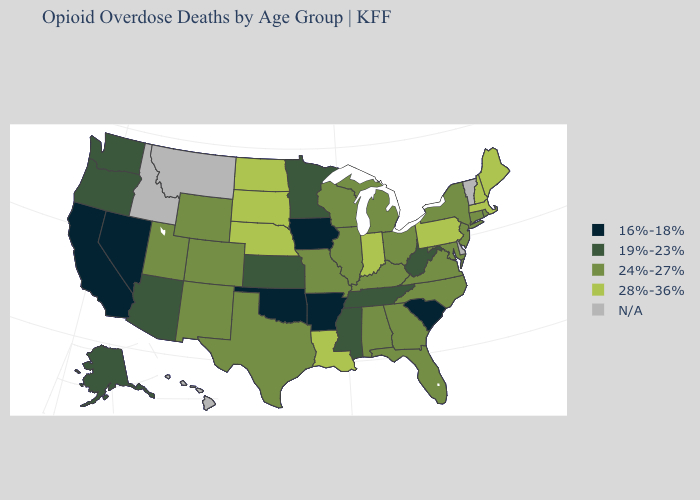What is the value of Virginia?
Give a very brief answer. 24%-27%. Which states hav the highest value in the Northeast?
Be succinct. Maine, Massachusetts, New Hampshire, Pennsylvania. What is the lowest value in the USA?
Concise answer only. 16%-18%. Does Florida have the highest value in the USA?
Short answer required. No. What is the highest value in the USA?
Keep it brief. 28%-36%. Name the states that have a value in the range 24%-27%?
Give a very brief answer. Alabama, Colorado, Connecticut, Florida, Georgia, Illinois, Kentucky, Maryland, Michigan, Missouri, New Jersey, New Mexico, New York, North Carolina, Ohio, Rhode Island, Texas, Utah, Virginia, Wisconsin, Wyoming. Name the states that have a value in the range 28%-36%?
Quick response, please. Indiana, Louisiana, Maine, Massachusetts, Nebraska, New Hampshire, North Dakota, Pennsylvania, South Dakota. Name the states that have a value in the range 28%-36%?
Be succinct. Indiana, Louisiana, Maine, Massachusetts, Nebraska, New Hampshire, North Dakota, Pennsylvania, South Dakota. What is the value of Louisiana?
Concise answer only. 28%-36%. Does the map have missing data?
Write a very short answer. Yes. What is the value of Connecticut?
Concise answer only. 24%-27%. Does the map have missing data?
Quick response, please. Yes. What is the value of Florida?
Give a very brief answer. 24%-27%. 